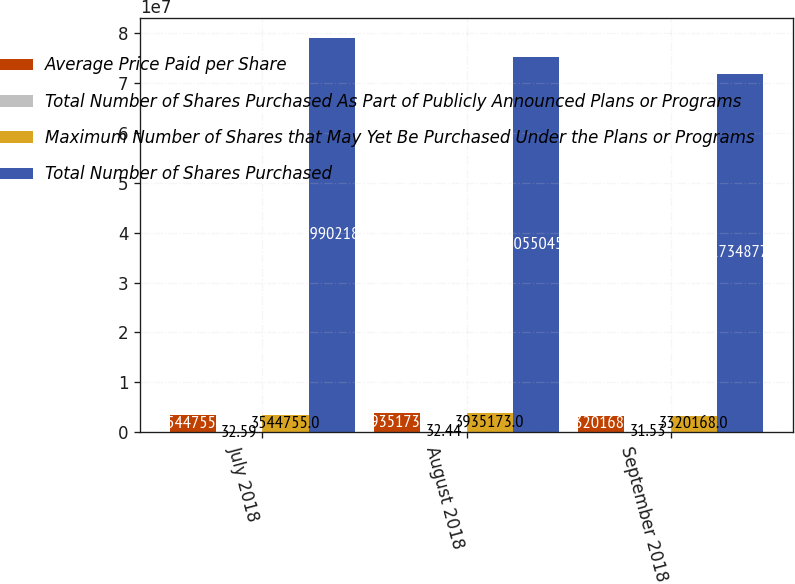Convert chart to OTSL. <chart><loc_0><loc_0><loc_500><loc_500><stacked_bar_chart><ecel><fcel>July 2018<fcel>August 2018<fcel>September 2018<nl><fcel>Average Price Paid per Share<fcel>3.54476e+06<fcel>3.93517e+06<fcel>3.32017e+06<nl><fcel>Total Number of Shares Purchased As Part of Publicly Announced Plans or Programs<fcel>32.59<fcel>32.44<fcel>31.53<nl><fcel>Maximum Number of Shares that May Yet Be Purchased Under the Plans or Programs<fcel>3.54476e+06<fcel>3.93517e+06<fcel>3.32017e+06<nl><fcel>Total Number of Shares Purchased<fcel>7.89902e+07<fcel>7.5055e+07<fcel>7.17349e+07<nl></chart> 